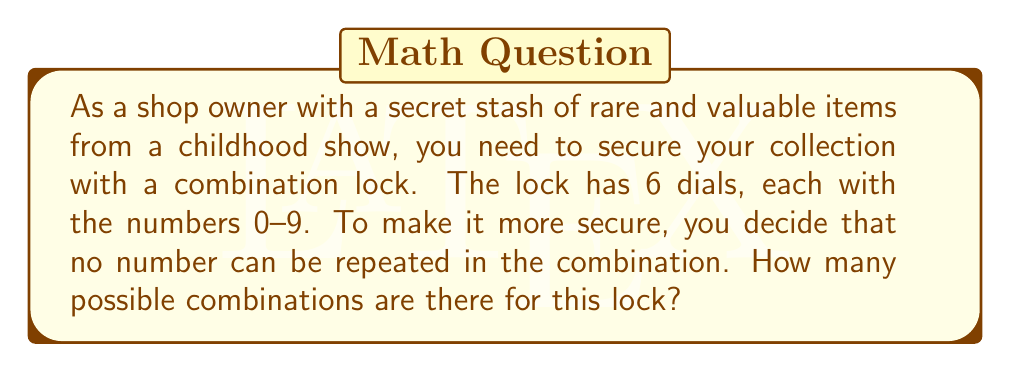Could you help me with this problem? Let's approach this step-by-step:

1) We are dealing with a permutation problem, as the order of the numbers matters and we can't repeat numbers.

2) We have 10 choices (0-9) for the first dial.

3) After choosing the first number, we have 9 choices left for the second dial.

4) For the third dial, we have 8 choices, and so on.

5) This continues until we reach the sixth dial, where we have 5 choices left.

6) The total number of combinations can be calculated using the multiplication principle:

   $$10 \times 9 \times 8 \times 7 \times 6 \times 5$$

7) This is equivalent to the permutation formula:

   $$P(10,6) = \frac{10!}{(10-6)!} = \frac{10!}{4!}$$

8) Let's calculate this:
   
   $$\frac{10!}{4!} = \frac{10 \times 9 \times 8 \times 7 \times 6 \times 5 \times 4!}{4!}$$

9) The 4! cancels out in the numerator and denominator:

   $$10 \times 9 \times 8 \times 7 \times 6 \times 5 = 151,200$$

Therefore, there are 151,200 possible combinations for this lock.
Answer: 151,200 